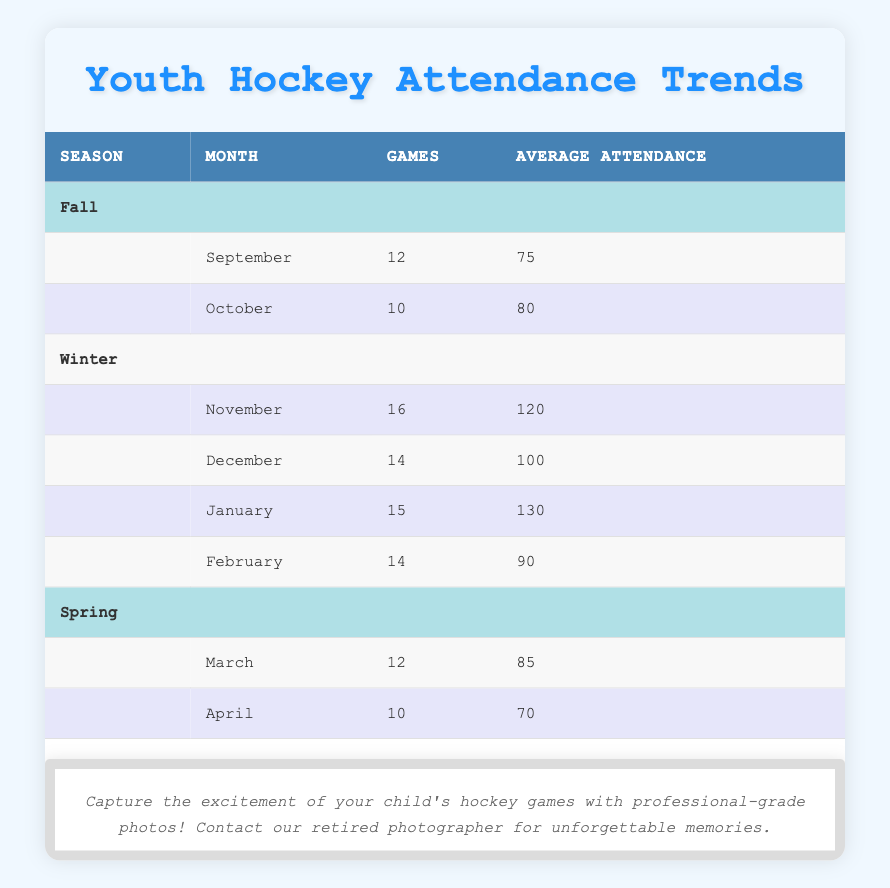What is the average attendance in January? There is one entry for January with an average attendance of 130. Since there is no calculation required (just a single value), the answer is directly obtained from the table.
Answer: 130 How many games were played in the winter season? The winter season has four months of attendance data: November (16 games), December (14 games), January (15 games), and February (14 games). Summing these values gives 16 + 14 + 15 + 14 = 59 games played in the winter season.
Answer: 59 Which month had the highest average attendance? By looking through all months listed, January has the highest average attendance at 130, compared to other months that have lower values. Thus, January holds the highest attendance value.
Answer: January Are there fewer games played in the spring than in the fall? Fall has 12 games in September and 10 games in October, summing to 12 + 10 = 22 games. Spring has 12 games in March and 10 games in April, summing to 12 + 10 = 22 games. Since they are equal, the answer is no.
Answer: No What is the total average attendance for the fall season? The average attendance for fall consists of September (75) and October (80). Adding these values and dividing by the two months gives (75 + 80) / 2 = 77.5, which is the total average attendance for the fall.
Answer: 77.5 Which month has the lowest average attendance and what is that number? By reviewing the average attendance values, April has the lowest attendance at 70 compared to other months. Identifying the minimum value shows April is the month with the lowest attendance.
Answer: April, 70 How many total games were played across all seasons? Summing all games across the three seasons: Fall (22 games), Winter (59 games), and Spring (22 games) gives a total of 22 + 59 + 22 = 103 games played across all seasons.
Answer: 103 Is the average attendance in winter higher than in the spring? The average attendance for winter includes four months (November - 120, December - 100, January - 130, February - 90), which sums to 440 and averages 440 / 4 = 110. In spring, the average attendance (March - 85, April - 70) averages to (85 + 70) / 2 = 77.5. Since 110 is greater than 77.5, the answer is yes.
Answer: Yes 